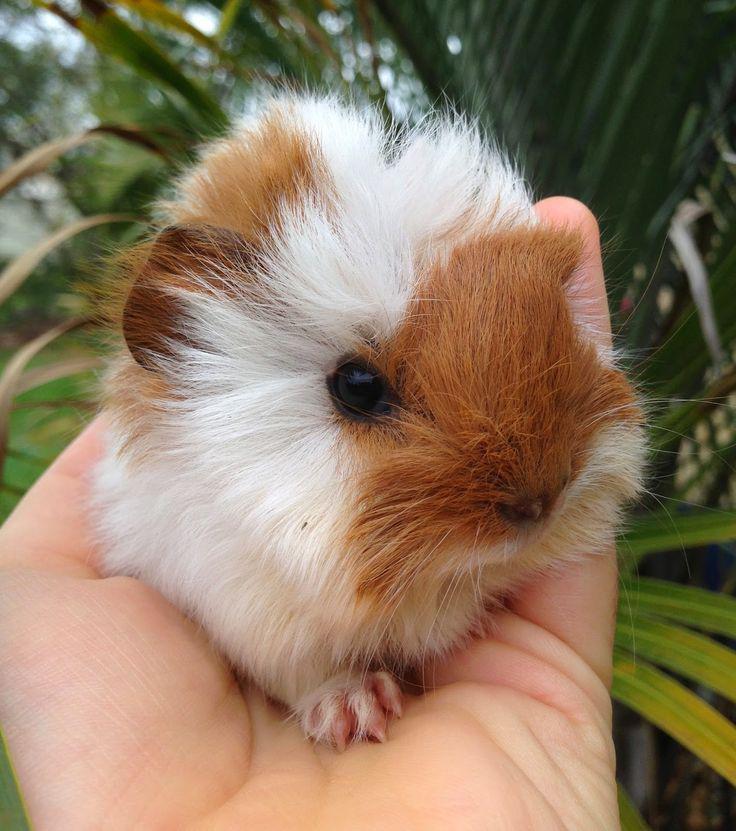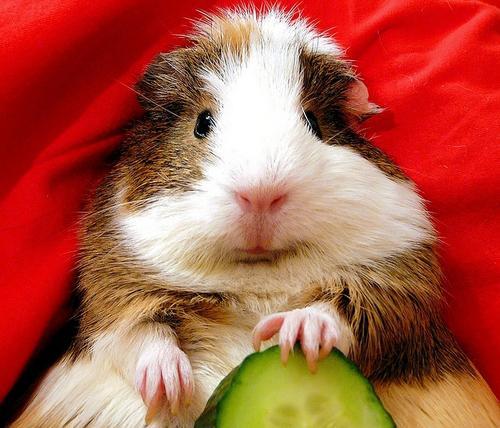The first image is the image on the left, the second image is the image on the right. Considering the images on both sides, is "The hamster on the right is depicted with produce-type food." valid? Answer yes or no. Yes. 